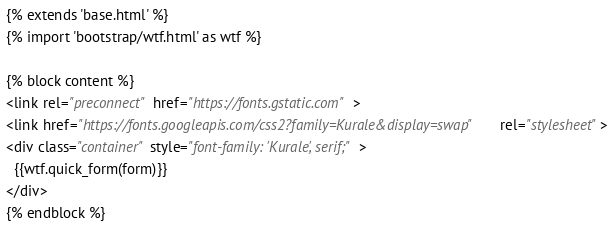<code> <loc_0><loc_0><loc_500><loc_500><_HTML_>{% extends 'base.html' %}
{% import 'bootstrap/wtf.html' as wtf %}

{% block content %}
<link rel="preconnect" href="https://fonts.gstatic.com">
<link href="https://fonts.googleapis.com/css2?family=Kurale&display=swap" rel="stylesheet">
<div class="container" style="font-family: 'Kurale', serif;">
  {{wtf.quick_form(form)}}
</div>
{% endblock %}
</code> 